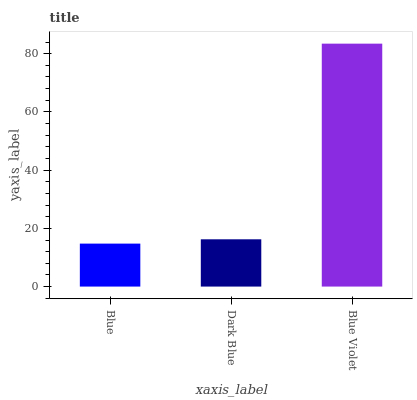Is Blue the minimum?
Answer yes or no. Yes. Is Blue Violet the maximum?
Answer yes or no. Yes. Is Dark Blue the minimum?
Answer yes or no. No. Is Dark Blue the maximum?
Answer yes or no. No. Is Dark Blue greater than Blue?
Answer yes or no. Yes. Is Blue less than Dark Blue?
Answer yes or no. Yes. Is Blue greater than Dark Blue?
Answer yes or no. No. Is Dark Blue less than Blue?
Answer yes or no. No. Is Dark Blue the high median?
Answer yes or no. Yes. Is Dark Blue the low median?
Answer yes or no. Yes. Is Blue the high median?
Answer yes or no. No. Is Blue Violet the low median?
Answer yes or no. No. 